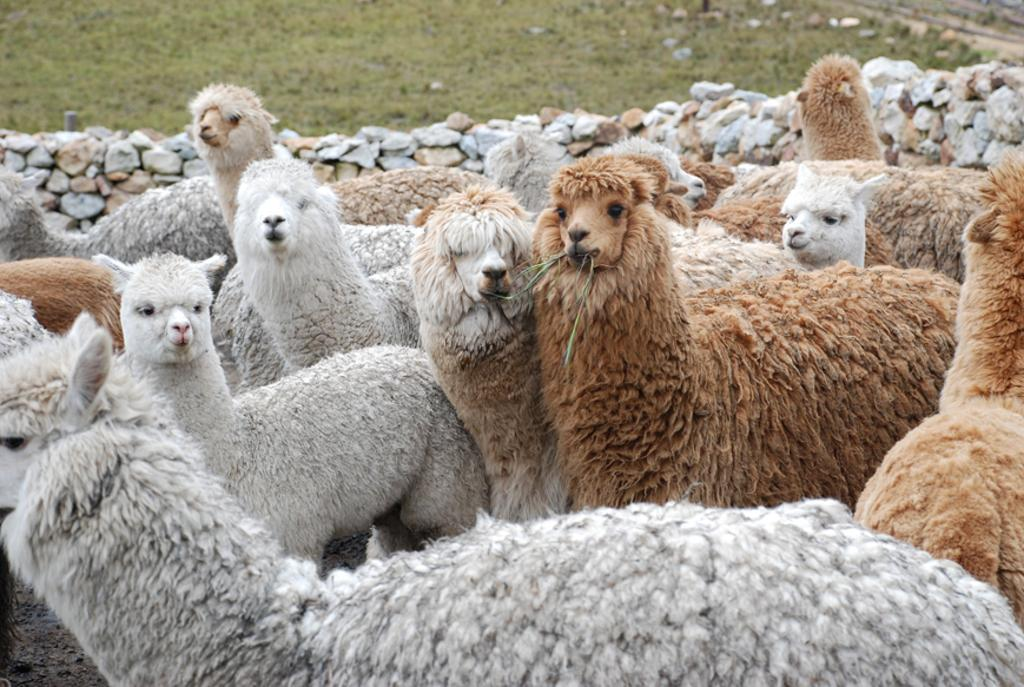What types of living organisms can be seen in the image? There are animals in the image. What can be seen in the background of the image? There is a stone wall in the background of the image. What type of vegetation is present on the ground in the image? Grass is present on the ground in the image. What color is the blood on the engine in the image? There is no blood or engine present in the image. 